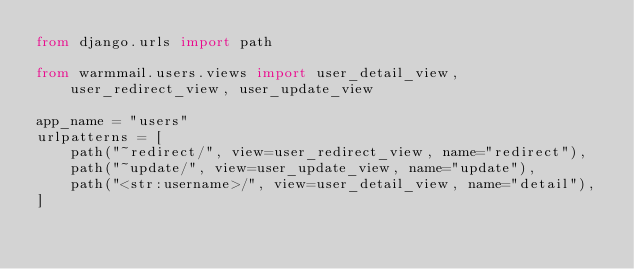Convert code to text. <code><loc_0><loc_0><loc_500><loc_500><_Python_>from django.urls import path

from warmmail.users.views import user_detail_view, user_redirect_view, user_update_view

app_name = "users"
urlpatterns = [
    path("~redirect/", view=user_redirect_view, name="redirect"),
    path("~update/", view=user_update_view, name="update"),
    path("<str:username>/", view=user_detail_view, name="detail"),
]
</code> 